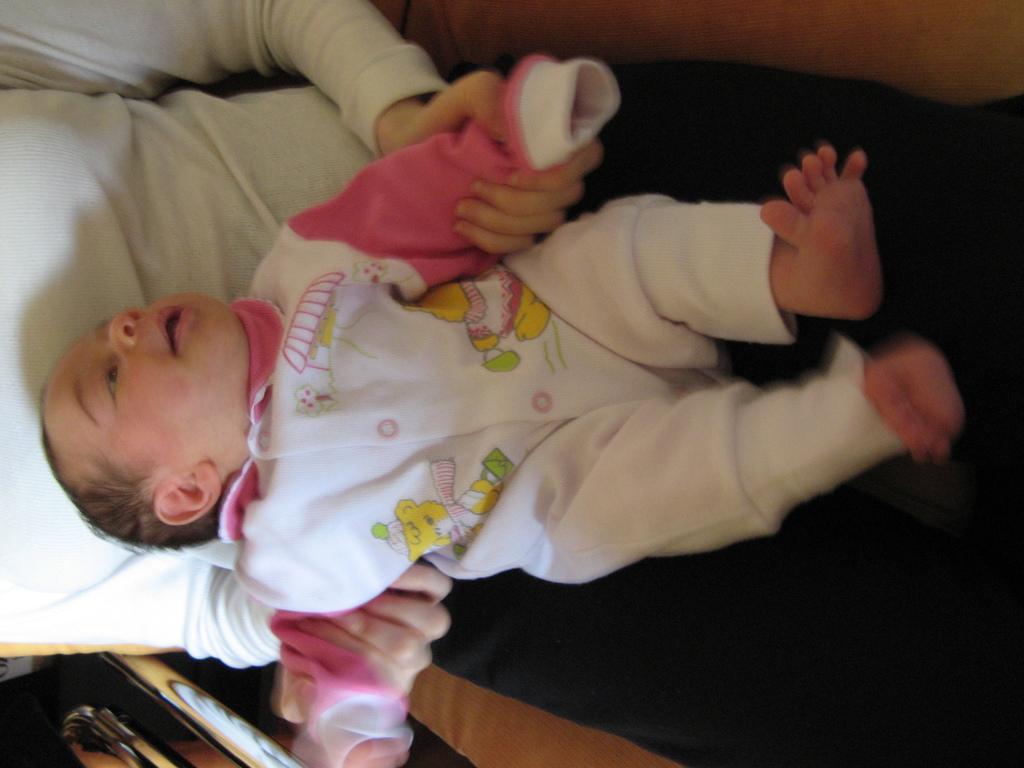Please provide a concise description of this image. In this picture there is a person sitting and holding the baby. At the bottom left there is an object and the baby is lying on the person. 